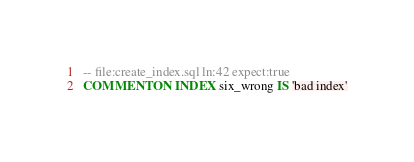<code> <loc_0><loc_0><loc_500><loc_500><_SQL_>-- file:create_index.sql ln:42 expect:true
COMMENT ON INDEX six_wrong IS 'bad index'
</code> 